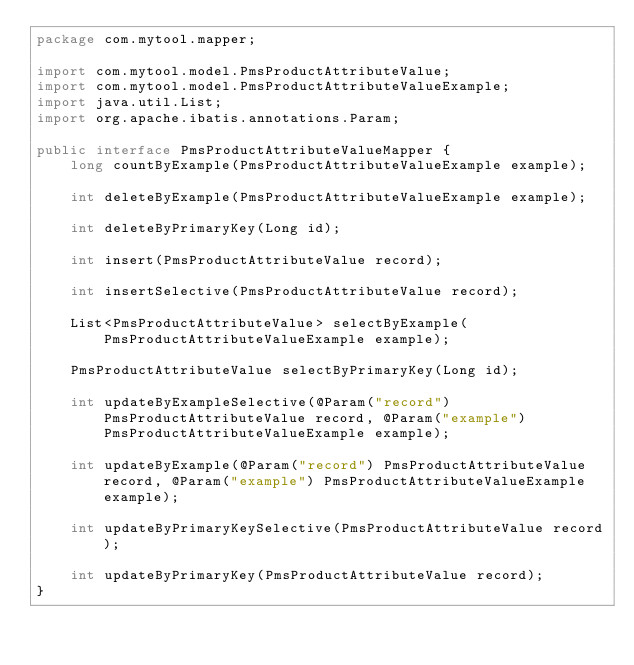Convert code to text. <code><loc_0><loc_0><loc_500><loc_500><_Java_>package com.mytool.mapper;

import com.mytool.model.PmsProductAttributeValue;
import com.mytool.model.PmsProductAttributeValueExample;
import java.util.List;
import org.apache.ibatis.annotations.Param;

public interface PmsProductAttributeValueMapper {
    long countByExample(PmsProductAttributeValueExample example);

    int deleteByExample(PmsProductAttributeValueExample example);

    int deleteByPrimaryKey(Long id);

    int insert(PmsProductAttributeValue record);

    int insertSelective(PmsProductAttributeValue record);

    List<PmsProductAttributeValue> selectByExample(PmsProductAttributeValueExample example);

    PmsProductAttributeValue selectByPrimaryKey(Long id);

    int updateByExampleSelective(@Param("record") PmsProductAttributeValue record, @Param("example") PmsProductAttributeValueExample example);

    int updateByExample(@Param("record") PmsProductAttributeValue record, @Param("example") PmsProductAttributeValueExample example);

    int updateByPrimaryKeySelective(PmsProductAttributeValue record);

    int updateByPrimaryKey(PmsProductAttributeValue record);
}</code> 